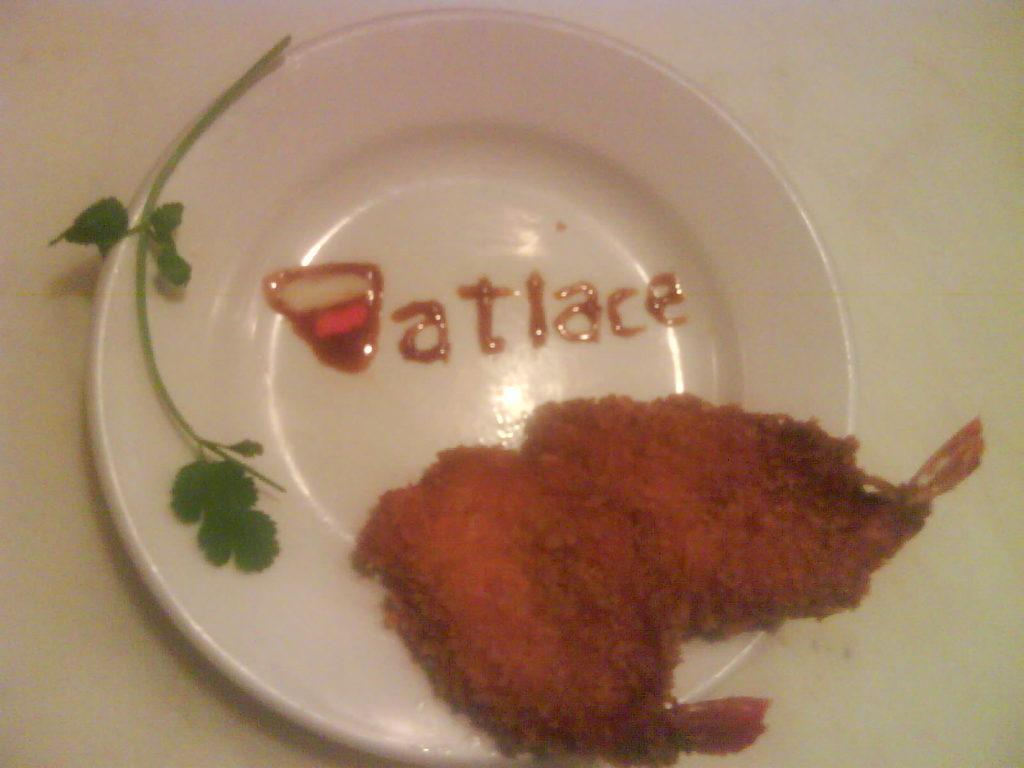What object is present on the white surface in the image? There is a plate on the white surface in the image. What is the color of the plate? The plate is on a white surface, but the plate itself is not mentioned as being white. What can be seen on the plate? There is text on the plate and a coriander leaf on the plate. What else is on the plate besides the coriander leaf? There is food on the plate. How much money is being cooked in the oven in the image? There is no oven or money present in the image. What type of pin is holding the coriander leaf in place on the plate? There is no pin mentioned in the image; the coriander leaf is simply placed on the plate. 